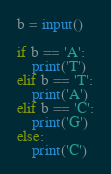<code> <loc_0><loc_0><loc_500><loc_500><_Python_>b = input()

if b == 'A':
	print('T')
elif b == 'T':
	print('A')
elif b == 'C':
	print('G')
else:
	print('C')</code> 